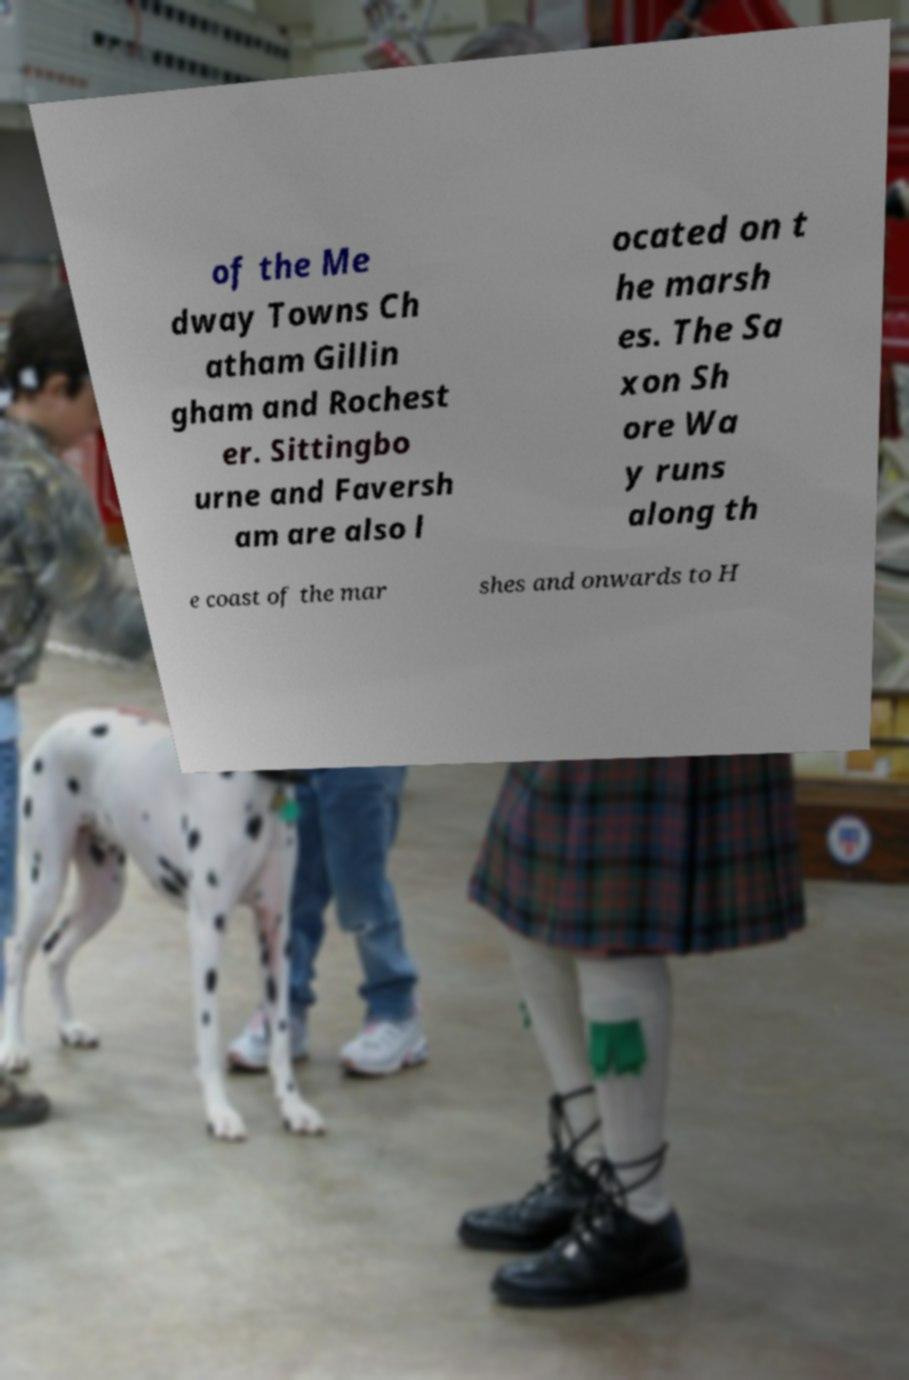For documentation purposes, I need the text within this image transcribed. Could you provide that? of the Me dway Towns Ch atham Gillin gham and Rochest er. Sittingbo urne and Faversh am are also l ocated on t he marsh es. The Sa xon Sh ore Wa y runs along th e coast of the mar shes and onwards to H 